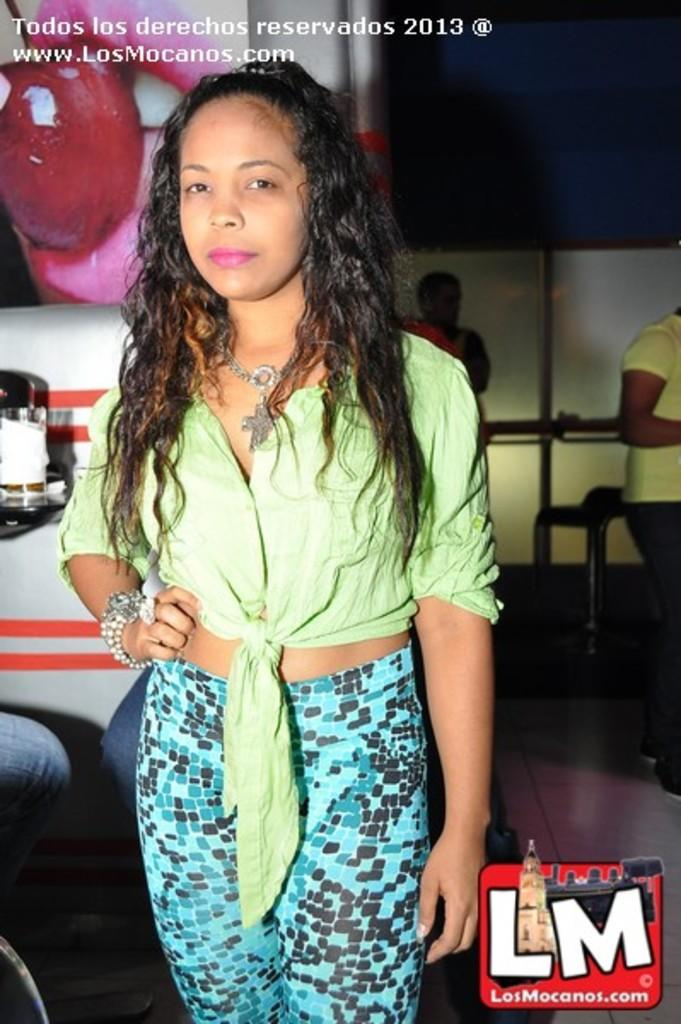What is the main subject of the image? There is a person standing in the image. Can you describe the person's attire? The person is wearing clothes. Is there any text or symbol in the image? Yes, there is a logo in the bottom right corner of the image. Are there any other people in the image? Yes, there is another person on the right side of the image. What color is the quicksand in the image? There is no quicksand present in the image. What holiday is being celebrated in the image? There is no indication of a holiday being celebrated in the image. 